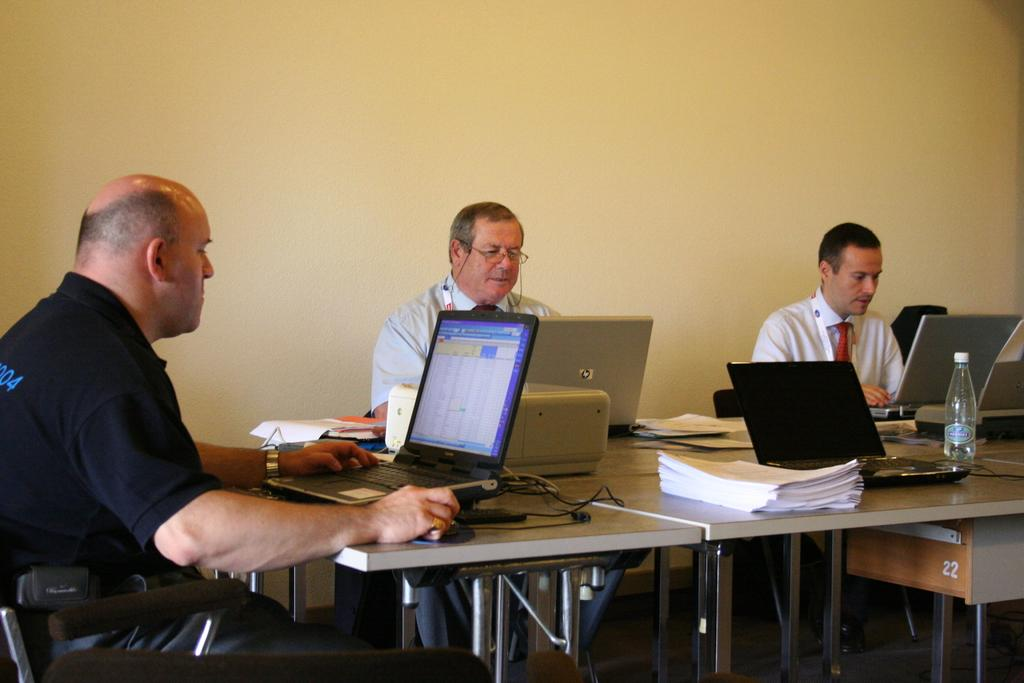How many people are in the image? There are three persons in the image. What are the persons doing in the image? The persons are sitting on a chair. What is present on the table in the image? There are papers, laptops, a printer, and a bottle on the table. What type of father can be seen sleeping in the image? There is no father or sleeping person present in the image. 